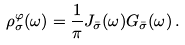<formula> <loc_0><loc_0><loc_500><loc_500>\rho _ { \sigma } ^ { \varphi } ( \omega ) = \frac { 1 } { \pi } J _ { \bar { \sigma } } ( \omega ) G _ { \bar { \sigma } } ( \omega ) \, .</formula> 